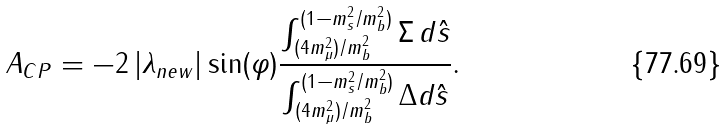Convert formula to latex. <formula><loc_0><loc_0><loc_500><loc_500>A _ { C P } = - 2 \, | \lambda _ { n e w } | \sin ( \varphi ) \frac { \int ^ { ( 1 - m _ { s } ^ { 2 } / m _ { b } ^ { 2 } ) } _ { ( 4 m ^ { 2 } _ { \mu } ) / m _ { b } ^ { 2 } } \Sigma \, d \hat { s } } { \int ^ { ( 1 - m _ { s } ^ { 2 } / m _ { b } ^ { 2 } ) } _ { ( 4 m ^ { 2 } _ { \mu } ) / m _ { b } ^ { 2 } } \Delta d \hat { s } } .</formula> 